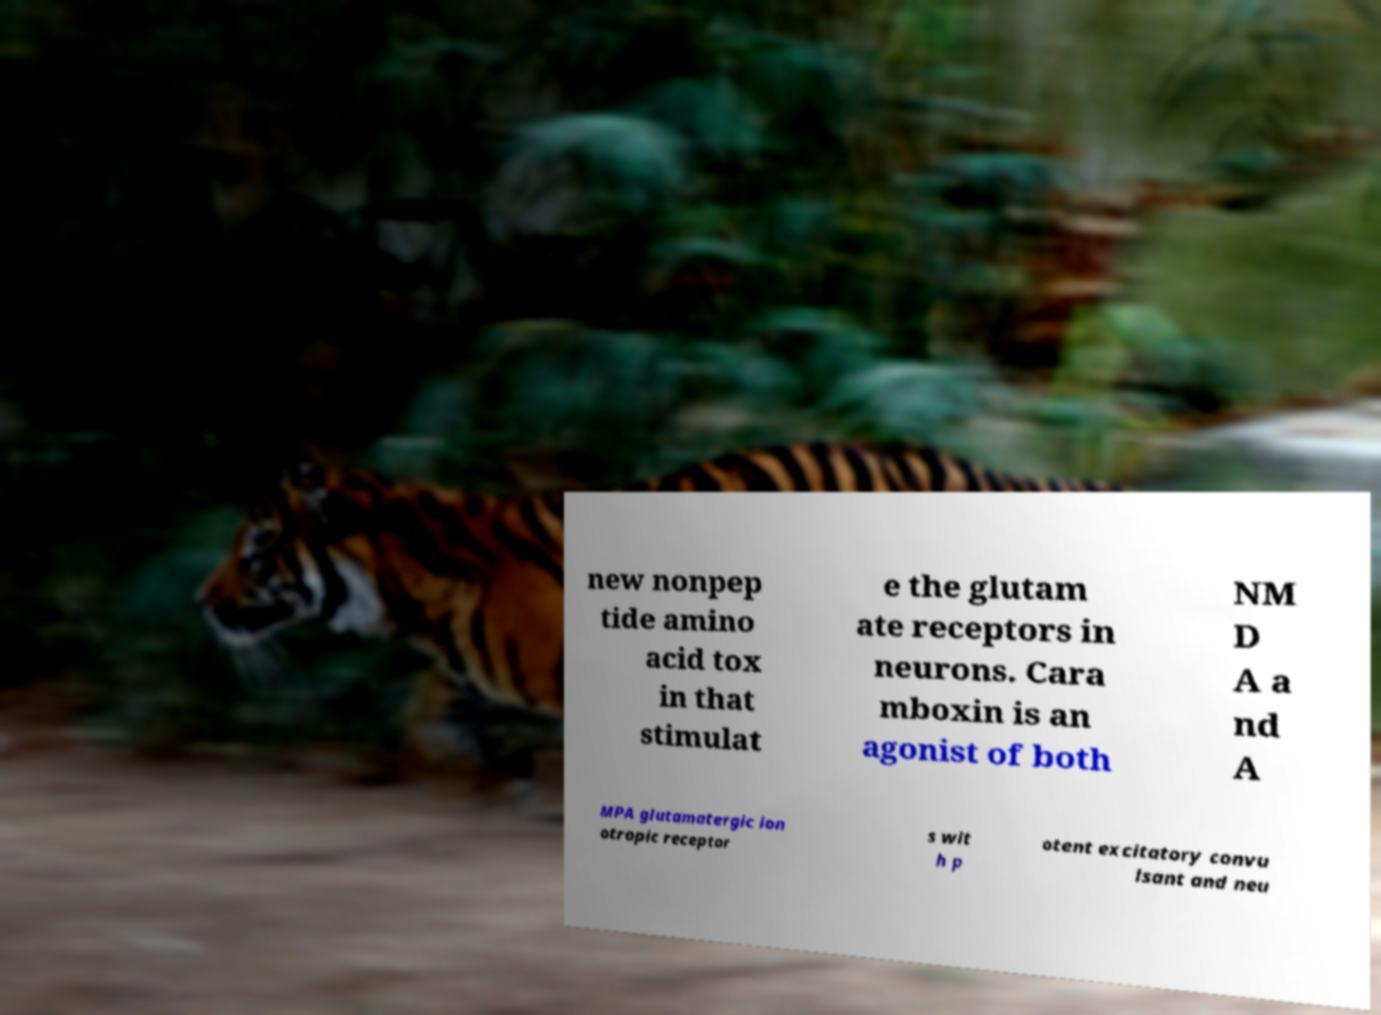Could you assist in decoding the text presented in this image and type it out clearly? new nonpep tide amino acid tox in that stimulat e the glutam ate receptors in neurons. Cara mboxin is an agonist of both NM D A a nd A MPA glutamatergic ion otropic receptor s wit h p otent excitatory convu lsant and neu 